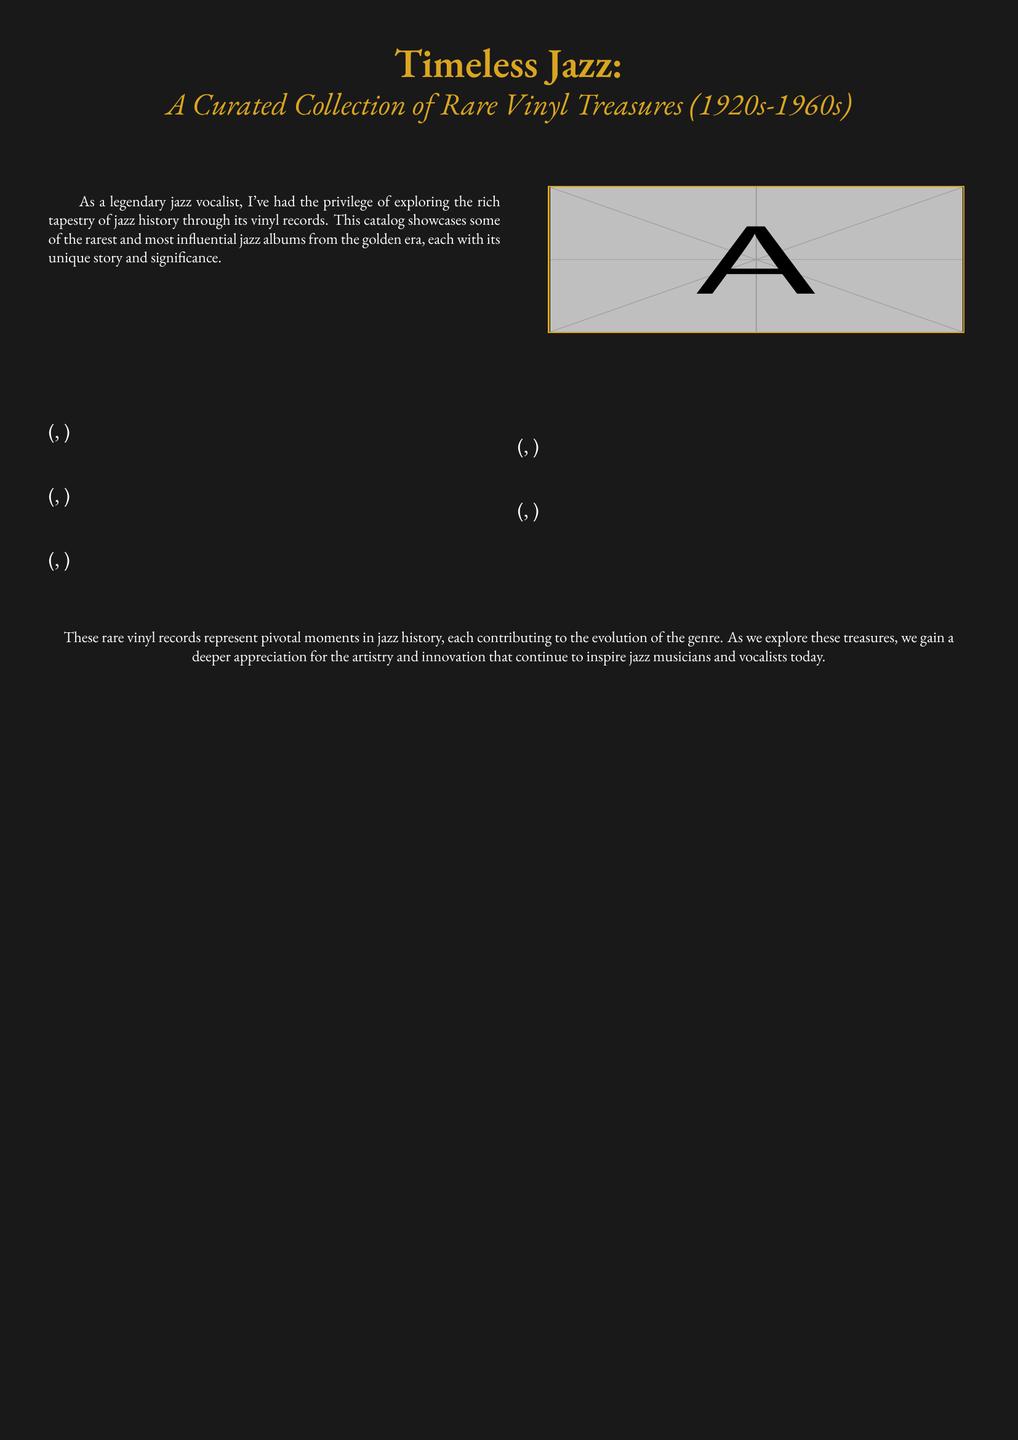What is the title of the catalog? The title of the catalog is prominently displayed at the top of the document, stating "Timeless Jazz".
Answer: Timeless Jazz What years does the catalog cover? The document mentions that the collection features vinyl records from the 1920s to the 1960s, indicating the range of years covered.
Answer: 1920s-1960s How many featured albums are listed in the document? The structure suggests there are five featured albums, as indicated by the loop mentioning "\x in {1,...,5}".
Answer: 5 What color is used for the document's background? The background color is defined as "jazzbg", which is specified in the document setup.
Answer: black Who is the main artist mentioned in the document? The document references the perspective of a "legendary jazz vocalist" who explores jazz history through vinyl records.
Answer: vocalist What significance do these records have in jazz history? The catalog explains that these records represent pivotal moments in jazz history and contribute to the evolution of the genre.
Answer: pivotal moments Which font is used in the document? The document specifies the main font as "EB Garamond", which is chosen for its elegance.
Answer: EB Garamond What theme do the album artworks reflect? The album artworks, as implied in the document, reflect "jazz" and its rich cultural significance through their design.
Answer: jazz What is the purpose of the catalog? The purpose is to showcase and celebrate rare jazz albums and their significance in jazz history.
Answer: showcase rare jazz albums 